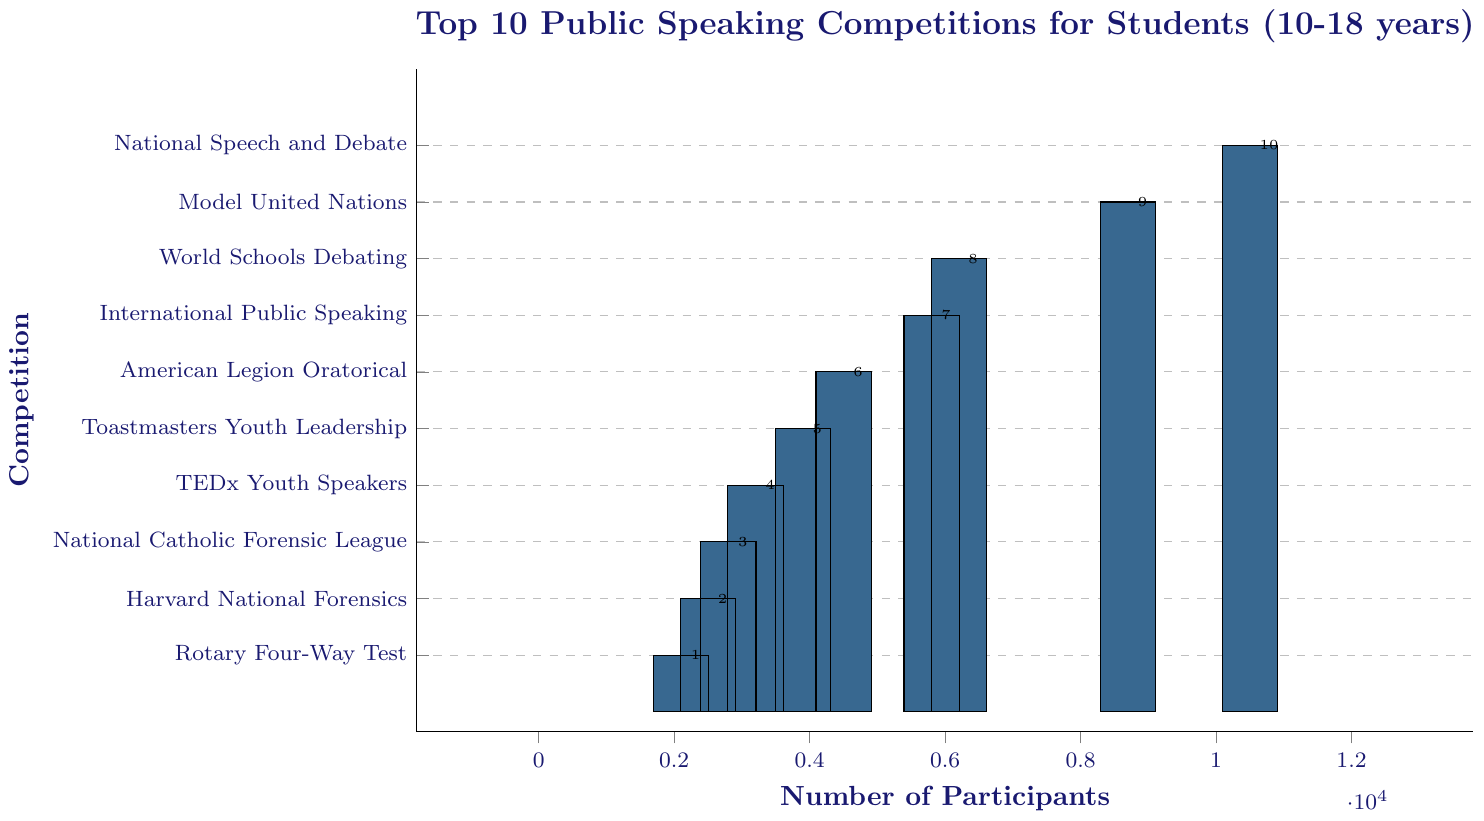Which competition has the highest number of participants? The competition with the highest bar represents the one with the highest number of participants. In this case, it corresponds to the "National Speech and Debate Association Tournament," which has 10,500 participants.
Answer: National Speech and Debate Association Tournament Which competition has the lowest number of participants? The competition with the shortest bar signifies the lowest number of participants. Here, that is the "Rotary Four-Way Test Speech Contest," with 2,100 participants.
Answer: Rotary Four-Way Test Speech Contest How many more participants does the Model United Nations have compared to the American Legion Oratorical Contest? The Model United Nations has 8,700 participants, while the American Legion Oratorical Contest has 4,500. The difference is 8,700 - 4,500 = 4,200 participants.
Answer: 4,200 What is the total number of participants for the top 3 competitions? The top 3 competitions are "National Speech and Debate Association Tournament" with 10,500, "Model United Nations" with 8,700, and "World Schools Debating Championships" with 6,200. The total is 10,500 + 8,700 + 6,200 = 25,400 participants.
Answer: 25,400 Which two competitions have the closest number of participants, and what is the difference? The "International Public Speaking Competition" has 5,800 participants, and the "World Schools Debating Championships" has 6,200. The difference is 6,200 - 5,800 = 400 participants.
Answer: International Public Speaking Competition and World Schools Debating Championships, 400 What is the combined number of participants for the bottom 5 competitions? The bottom 5 competitions are "Rotary Four-Way Test Speech Contest" (2,100), "Harvard National Forensics Tournament" (2,500), "National Catholic Forensic League Grand National Tournament" (2,800), "TEDx Youth Speakers" (3,200), and "Toastmasters Youth Leadership Program" (3,900). The total is 2,100 + 2,500 + 2,800 + 3,200 + 3,900 = 14,500 participants.
Answer: 14,500 Which competition's number of participants is closest to the average number of participants across all competitions? First, find the average number of participants: (10,500 + 8,700 + 6,200 + 5,800 + 4,500 + 3,900 + 3,200 + 2,800 + 2,500 + 2,100) / 10 = 50,200 / 10 = 5,020. The closest competition is the "International Public Speaking Competition" with 5,800 participants.
Answer: International Public Speaking Competition How many more participants are there in the "National Speech and Debate Association Tournament" compared to the "Toastmasters Youth Leadership Program"? The "National Speech and Debate Association Tournament" has 10,500 participants, and the "Toastmasters Youth Leadership Program" has 3,900. The difference is 10,500 - 3,900 = 6,600 participants.
Answer: 6,600 What is the difference in the number of participants between the "TEDx Youth Speakers" and the "Harvard National Forensics Tournament"? The "TEDx Youth Speakers" has 3,200 participants, while the "Harvard National Forensics Tournament" has 2,500. The difference is 3,200 - 2,500 = 700 participants.
Answer: 700 